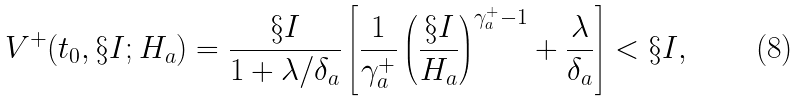Convert formula to latex. <formula><loc_0><loc_0><loc_500><loc_500>V ^ { + } ( t _ { 0 } , \S I ; H _ { a } ) = \frac { \S I } { 1 + \lambda / \delta _ { a } } \left [ \frac { 1 } { \gamma ^ { + } _ { a } } \left ( \frac { \S I } { H _ { a } } \right ) ^ { \gamma ^ { + } _ { a } - 1 } + \frac { \lambda } { \delta _ { a } } \right ] < \S I ,</formula> 